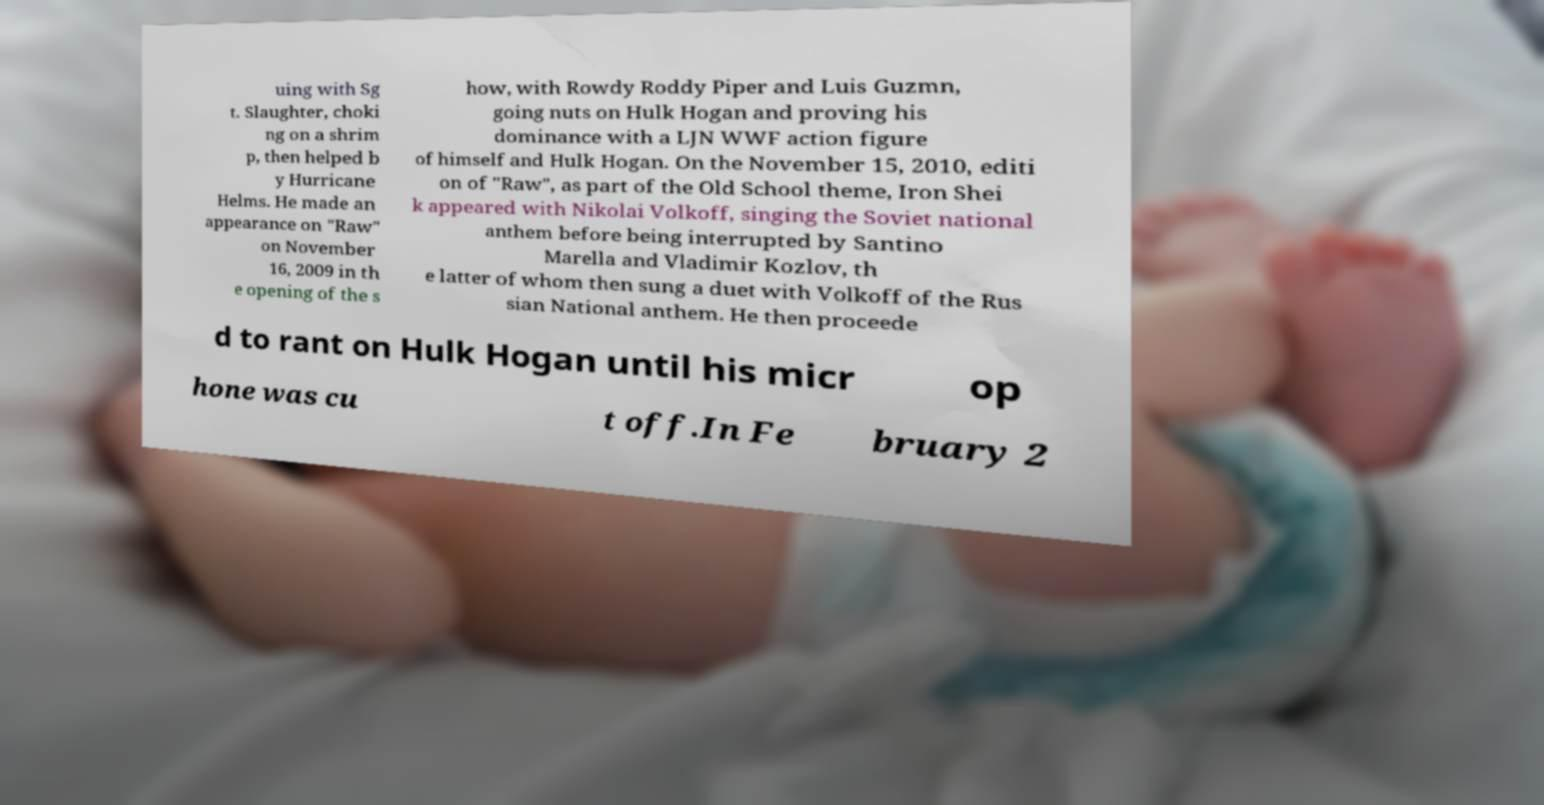Please identify and transcribe the text found in this image. uing with Sg t. Slaughter, choki ng on a shrim p, then helped b y Hurricane Helms. He made an appearance on "Raw" on November 16, 2009 in th e opening of the s how, with Rowdy Roddy Piper and Luis Guzmn, going nuts on Hulk Hogan and proving his dominance with a LJN WWF action figure of himself and Hulk Hogan. On the November 15, 2010, editi on of "Raw", as part of the Old School theme, Iron Shei k appeared with Nikolai Volkoff, singing the Soviet national anthem before being interrupted by Santino Marella and Vladimir Kozlov, th e latter of whom then sung a duet with Volkoff of the Rus sian National anthem. He then proceede d to rant on Hulk Hogan until his micr op hone was cu t off.In Fe bruary 2 